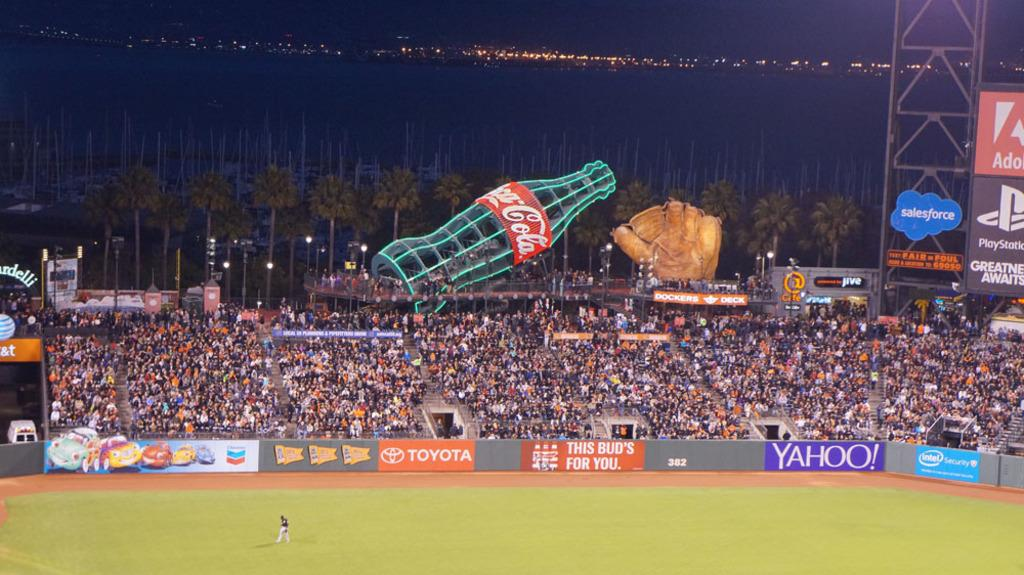<image>
Create a compact narrative representing the image presented. a babseball field with a packed stadium sponsored by toyota yahoo and coca-cola 